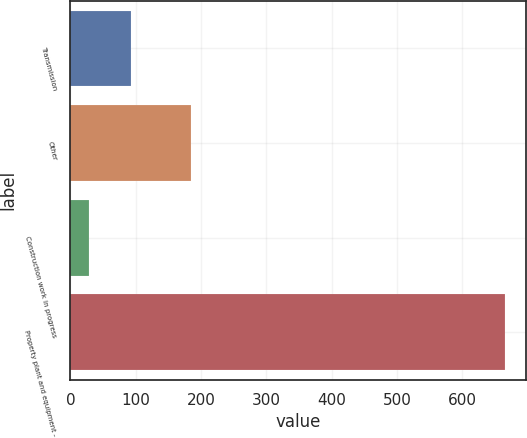<chart> <loc_0><loc_0><loc_500><loc_500><bar_chart><fcel>Transmission<fcel>Other<fcel>Construction work in progress<fcel>Property plant and equipment -<nl><fcel>92.6<fcel>184<fcel>29<fcel>665<nl></chart> 